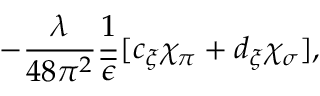<formula> <loc_0><loc_0><loc_500><loc_500>- \frac { \lambda } { 4 8 \pi ^ { 2 } } \frac { 1 } { \overline { \epsilon } } [ c _ { \xi } \chi _ { \pi } + d _ { \xi } \chi _ { \sigma } ] ,</formula> 